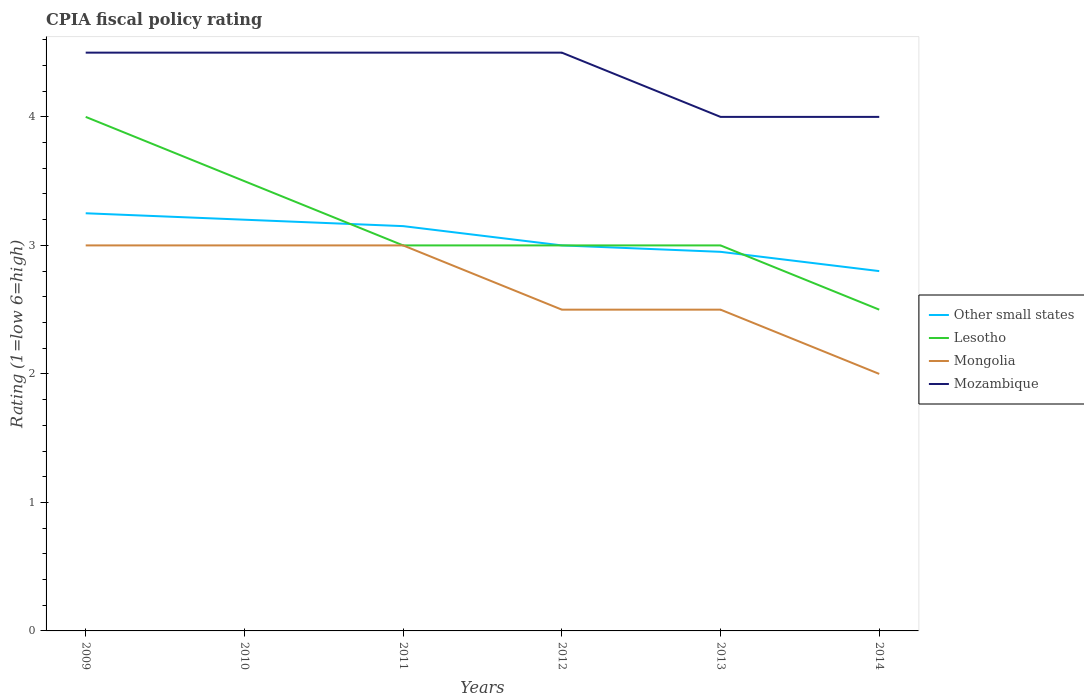Across all years, what is the maximum CPIA rating in Mozambique?
Your answer should be compact. 4. What is the total CPIA rating in Other small states in the graph?
Provide a succinct answer. 0.2. What is the difference between the highest and the second highest CPIA rating in Mongolia?
Ensure brevity in your answer.  1. What is the difference between the highest and the lowest CPIA rating in Lesotho?
Keep it short and to the point. 2. Is the CPIA rating in Mozambique strictly greater than the CPIA rating in Lesotho over the years?
Your answer should be very brief. No. How many years are there in the graph?
Your answer should be compact. 6. What is the difference between two consecutive major ticks on the Y-axis?
Your answer should be very brief. 1. Are the values on the major ticks of Y-axis written in scientific E-notation?
Keep it short and to the point. No. Does the graph contain grids?
Provide a short and direct response. No. What is the title of the graph?
Offer a terse response. CPIA fiscal policy rating. What is the Rating (1=low 6=high) in Other small states in 2009?
Keep it short and to the point. 3.25. What is the Rating (1=low 6=high) of Other small states in 2010?
Your answer should be very brief. 3.2. What is the Rating (1=low 6=high) of Lesotho in 2010?
Give a very brief answer. 3.5. What is the Rating (1=low 6=high) in Mongolia in 2010?
Your response must be concise. 3. What is the Rating (1=low 6=high) in Other small states in 2011?
Provide a succinct answer. 3.15. What is the Rating (1=low 6=high) in Lesotho in 2011?
Your answer should be very brief. 3. What is the Rating (1=low 6=high) in Other small states in 2012?
Make the answer very short. 3. What is the Rating (1=low 6=high) in Mongolia in 2012?
Ensure brevity in your answer.  2.5. What is the Rating (1=low 6=high) in Mozambique in 2012?
Give a very brief answer. 4.5. What is the Rating (1=low 6=high) in Other small states in 2013?
Give a very brief answer. 2.95. What is the Rating (1=low 6=high) of Lesotho in 2013?
Make the answer very short. 3. What is the Rating (1=low 6=high) of Mozambique in 2013?
Make the answer very short. 4. What is the Rating (1=low 6=high) of Mongolia in 2014?
Your response must be concise. 2. Across all years, what is the maximum Rating (1=low 6=high) in Lesotho?
Your answer should be very brief. 4. Across all years, what is the maximum Rating (1=low 6=high) of Mongolia?
Your answer should be very brief. 3. Across all years, what is the maximum Rating (1=low 6=high) of Mozambique?
Provide a short and direct response. 4.5. Across all years, what is the minimum Rating (1=low 6=high) in Lesotho?
Make the answer very short. 2.5. Across all years, what is the minimum Rating (1=low 6=high) in Mongolia?
Your response must be concise. 2. Across all years, what is the minimum Rating (1=low 6=high) in Mozambique?
Your answer should be very brief. 4. What is the total Rating (1=low 6=high) in Other small states in the graph?
Provide a short and direct response. 18.35. What is the difference between the Rating (1=low 6=high) in Lesotho in 2009 and that in 2010?
Make the answer very short. 0.5. What is the difference between the Rating (1=low 6=high) in Mongolia in 2009 and that in 2010?
Your answer should be very brief. 0. What is the difference between the Rating (1=low 6=high) in Mozambique in 2009 and that in 2010?
Provide a short and direct response. 0. What is the difference between the Rating (1=low 6=high) in Lesotho in 2009 and that in 2011?
Ensure brevity in your answer.  1. What is the difference between the Rating (1=low 6=high) in Mongolia in 2009 and that in 2011?
Provide a succinct answer. 0. What is the difference between the Rating (1=low 6=high) in Other small states in 2009 and that in 2012?
Ensure brevity in your answer.  0.25. What is the difference between the Rating (1=low 6=high) of Lesotho in 2009 and that in 2012?
Give a very brief answer. 1. What is the difference between the Rating (1=low 6=high) in Other small states in 2009 and that in 2013?
Your answer should be very brief. 0.3. What is the difference between the Rating (1=low 6=high) of Mozambique in 2009 and that in 2013?
Your answer should be very brief. 0.5. What is the difference between the Rating (1=low 6=high) of Other small states in 2009 and that in 2014?
Make the answer very short. 0.45. What is the difference between the Rating (1=low 6=high) in Mongolia in 2009 and that in 2014?
Your answer should be very brief. 1. What is the difference between the Rating (1=low 6=high) in Mozambique in 2009 and that in 2014?
Your response must be concise. 0.5. What is the difference between the Rating (1=low 6=high) of Other small states in 2010 and that in 2011?
Your answer should be compact. 0.05. What is the difference between the Rating (1=low 6=high) of Lesotho in 2010 and that in 2011?
Give a very brief answer. 0.5. What is the difference between the Rating (1=low 6=high) of Mozambique in 2010 and that in 2012?
Provide a succinct answer. 0. What is the difference between the Rating (1=low 6=high) of Other small states in 2010 and that in 2013?
Your response must be concise. 0.25. What is the difference between the Rating (1=low 6=high) in Mozambique in 2010 and that in 2013?
Your response must be concise. 0.5. What is the difference between the Rating (1=low 6=high) in Other small states in 2010 and that in 2014?
Give a very brief answer. 0.4. What is the difference between the Rating (1=low 6=high) of Lesotho in 2010 and that in 2014?
Your response must be concise. 1. What is the difference between the Rating (1=low 6=high) in Mozambique in 2010 and that in 2014?
Keep it short and to the point. 0.5. What is the difference between the Rating (1=low 6=high) in Other small states in 2011 and that in 2012?
Keep it short and to the point. 0.15. What is the difference between the Rating (1=low 6=high) of Other small states in 2011 and that in 2013?
Your answer should be very brief. 0.2. What is the difference between the Rating (1=low 6=high) in Mozambique in 2011 and that in 2013?
Keep it short and to the point. 0.5. What is the difference between the Rating (1=low 6=high) of Other small states in 2011 and that in 2014?
Make the answer very short. 0.35. What is the difference between the Rating (1=low 6=high) of Mongolia in 2011 and that in 2014?
Provide a succinct answer. 1. What is the difference between the Rating (1=low 6=high) in Mongolia in 2012 and that in 2013?
Offer a terse response. 0. What is the difference between the Rating (1=low 6=high) in Other small states in 2012 and that in 2014?
Your response must be concise. 0.2. What is the difference between the Rating (1=low 6=high) of Lesotho in 2012 and that in 2014?
Offer a very short reply. 0.5. What is the difference between the Rating (1=low 6=high) of Mongolia in 2012 and that in 2014?
Your answer should be very brief. 0.5. What is the difference between the Rating (1=low 6=high) of Mozambique in 2012 and that in 2014?
Ensure brevity in your answer.  0.5. What is the difference between the Rating (1=low 6=high) of Other small states in 2013 and that in 2014?
Give a very brief answer. 0.15. What is the difference between the Rating (1=low 6=high) in Mozambique in 2013 and that in 2014?
Offer a very short reply. 0. What is the difference between the Rating (1=low 6=high) of Other small states in 2009 and the Rating (1=low 6=high) of Mongolia in 2010?
Offer a terse response. 0.25. What is the difference between the Rating (1=low 6=high) of Other small states in 2009 and the Rating (1=low 6=high) of Mozambique in 2010?
Your answer should be very brief. -1.25. What is the difference between the Rating (1=low 6=high) of Lesotho in 2009 and the Rating (1=low 6=high) of Mozambique in 2010?
Offer a terse response. -0.5. What is the difference between the Rating (1=low 6=high) in Mongolia in 2009 and the Rating (1=low 6=high) in Mozambique in 2010?
Ensure brevity in your answer.  -1.5. What is the difference between the Rating (1=low 6=high) in Other small states in 2009 and the Rating (1=low 6=high) in Lesotho in 2011?
Offer a very short reply. 0.25. What is the difference between the Rating (1=low 6=high) in Other small states in 2009 and the Rating (1=low 6=high) in Mongolia in 2011?
Offer a terse response. 0.25. What is the difference between the Rating (1=low 6=high) in Other small states in 2009 and the Rating (1=low 6=high) in Mozambique in 2011?
Ensure brevity in your answer.  -1.25. What is the difference between the Rating (1=low 6=high) in Lesotho in 2009 and the Rating (1=low 6=high) in Mongolia in 2011?
Provide a short and direct response. 1. What is the difference between the Rating (1=low 6=high) in Other small states in 2009 and the Rating (1=low 6=high) in Mongolia in 2012?
Your answer should be very brief. 0.75. What is the difference between the Rating (1=low 6=high) of Other small states in 2009 and the Rating (1=low 6=high) of Mozambique in 2012?
Give a very brief answer. -1.25. What is the difference between the Rating (1=low 6=high) of Other small states in 2009 and the Rating (1=low 6=high) of Mozambique in 2013?
Offer a very short reply. -0.75. What is the difference between the Rating (1=low 6=high) of Lesotho in 2009 and the Rating (1=low 6=high) of Mozambique in 2013?
Ensure brevity in your answer.  0. What is the difference between the Rating (1=low 6=high) in Mongolia in 2009 and the Rating (1=low 6=high) in Mozambique in 2013?
Your response must be concise. -1. What is the difference between the Rating (1=low 6=high) in Other small states in 2009 and the Rating (1=low 6=high) in Lesotho in 2014?
Your response must be concise. 0.75. What is the difference between the Rating (1=low 6=high) in Other small states in 2009 and the Rating (1=low 6=high) in Mozambique in 2014?
Your response must be concise. -0.75. What is the difference between the Rating (1=low 6=high) of Lesotho in 2009 and the Rating (1=low 6=high) of Mozambique in 2014?
Offer a terse response. 0. What is the difference between the Rating (1=low 6=high) of Mongolia in 2009 and the Rating (1=low 6=high) of Mozambique in 2014?
Keep it short and to the point. -1. What is the difference between the Rating (1=low 6=high) of Other small states in 2010 and the Rating (1=low 6=high) of Mozambique in 2011?
Provide a succinct answer. -1.3. What is the difference between the Rating (1=low 6=high) of Lesotho in 2010 and the Rating (1=low 6=high) of Mozambique in 2011?
Your answer should be very brief. -1. What is the difference between the Rating (1=low 6=high) of Other small states in 2010 and the Rating (1=low 6=high) of Lesotho in 2012?
Keep it short and to the point. 0.2. What is the difference between the Rating (1=low 6=high) of Other small states in 2010 and the Rating (1=low 6=high) of Mongolia in 2012?
Keep it short and to the point. 0.7. What is the difference between the Rating (1=low 6=high) of Other small states in 2010 and the Rating (1=low 6=high) of Mozambique in 2012?
Provide a short and direct response. -1.3. What is the difference between the Rating (1=low 6=high) in Lesotho in 2010 and the Rating (1=low 6=high) in Mozambique in 2012?
Make the answer very short. -1. What is the difference between the Rating (1=low 6=high) in Other small states in 2010 and the Rating (1=low 6=high) in Lesotho in 2013?
Keep it short and to the point. 0.2. What is the difference between the Rating (1=low 6=high) of Other small states in 2010 and the Rating (1=low 6=high) of Mongolia in 2013?
Provide a succinct answer. 0.7. What is the difference between the Rating (1=low 6=high) of Other small states in 2010 and the Rating (1=low 6=high) of Mozambique in 2013?
Offer a terse response. -0.8. What is the difference between the Rating (1=low 6=high) of Lesotho in 2010 and the Rating (1=low 6=high) of Mozambique in 2013?
Make the answer very short. -0.5. What is the difference between the Rating (1=low 6=high) of Mongolia in 2010 and the Rating (1=low 6=high) of Mozambique in 2013?
Give a very brief answer. -1. What is the difference between the Rating (1=low 6=high) in Other small states in 2010 and the Rating (1=low 6=high) in Mongolia in 2014?
Keep it short and to the point. 1.2. What is the difference between the Rating (1=low 6=high) in Other small states in 2010 and the Rating (1=low 6=high) in Mozambique in 2014?
Keep it short and to the point. -0.8. What is the difference between the Rating (1=low 6=high) of Lesotho in 2010 and the Rating (1=low 6=high) of Mozambique in 2014?
Provide a succinct answer. -0.5. What is the difference between the Rating (1=low 6=high) of Other small states in 2011 and the Rating (1=low 6=high) of Mongolia in 2012?
Ensure brevity in your answer.  0.65. What is the difference between the Rating (1=low 6=high) in Other small states in 2011 and the Rating (1=low 6=high) in Mozambique in 2012?
Keep it short and to the point. -1.35. What is the difference between the Rating (1=low 6=high) of Lesotho in 2011 and the Rating (1=low 6=high) of Mongolia in 2012?
Your response must be concise. 0.5. What is the difference between the Rating (1=low 6=high) in Lesotho in 2011 and the Rating (1=low 6=high) in Mozambique in 2012?
Make the answer very short. -1.5. What is the difference between the Rating (1=low 6=high) of Other small states in 2011 and the Rating (1=low 6=high) of Mongolia in 2013?
Give a very brief answer. 0.65. What is the difference between the Rating (1=low 6=high) in Other small states in 2011 and the Rating (1=low 6=high) in Mozambique in 2013?
Provide a short and direct response. -0.85. What is the difference between the Rating (1=low 6=high) in Lesotho in 2011 and the Rating (1=low 6=high) in Mozambique in 2013?
Provide a short and direct response. -1. What is the difference between the Rating (1=low 6=high) in Mongolia in 2011 and the Rating (1=low 6=high) in Mozambique in 2013?
Your response must be concise. -1. What is the difference between the Rating (1=low 6=high) of Other small states in 2011 and the Rating (1=low 6=high) of Lesotho in 2014?
Your answer should be very brief. 0.65. What is the difference between the Rating (1=low 6=high) in Other small states in 2011 and the Rating (1=low 6=high) in Mongolia in 2014?
Your answer should be compact. 1.15. What is the difference between the Rating (1=low 6=high) in Other small states in 2011 and the Rating (1=low 6=high) in Mozambique in 2014?
Provide a succinct answer. -0.85. What is the difference between the Rating (1=low 6=high) in Other small states in 2012 and the Rating (1=low 6=high) in Mongolia in 2013?
Provide a succinct answer. 0.5. What is the difference between the Rating (1=low 6=high) of Other small states in 2012 and the Rating (1=low 6=high) of Mozambique in 2013?
Provide a succinct answer. -1. What is the difference between the Rating (1=low 6=high) of Lesotho in 2012 and the Rating (1=low 6=high) of Mongolia in 2013?
Give a very brief answer. 0.5. What is the difference between the Rating (1=low 6=high) in Mongolia in 2012 and the Rating (1=low 6=high) in Mozambique in 2013?
Your response must be concise. -1.5. What is the difference between the Rating (1=low 6=high) of Other small states in 2012 and the Rating (1=low 6=high) of Lesotho in 2014?
Keep it short and to the point. 0.5. What is the difference between the Rating (1=low 6=high) of Lesotho in 2012 and the Rating (1=low 6=high) of Mozambique in 2014?
Your answer should be compact. -1. What is the difference between the Rating (1=low 6=high) of Other small states in 2013 and the Rating (1=low 6=high) of Lesotho in 2014?
Your response must be concise. 0.45. What is the difference between the Rating (1=low 6=high) in Other small states in 2013 and the Rating (1=low 6=high) in Mongolia in 2014?
Provide a succinct answer. 0.95. What is the difference between the Rating (1=low 6=high) of Other small states in 2013 and the Rating (1=low 6=high) of Mozambique in 2014?
Your answer should be compact. -1.05. What is the difference between the Rating (1=low 6=high) in Lesotho in 2013 and the Rating (1=low 6=high) in Mozambique in 2014?
Offer a very short reply. -1. What is the difference between the Rating (1=low 6=high) in Mongolia in 2013 and the Rating (1=low 6=high) in Mozambique in 2014?
Make the answer very short. -1.5. What is the average Rating (1=low 6=high) of Other small states per year?
Offer a very short reply. 3.06. What is the average Rating (1=low 6=high) of Lesotho per year?
Your answer should be very brief. 3.17. What is the average Rating (1=low 6=high) in Mongolia per year?
Your answer should be very brief. 2.67. What is the average Rating (1=low 6=high) of Mozambique per year?
Provide a succinct answer. 4.33. In the year 2009, what is the difference between the Rating (1=low 6=high) of Other small states and Rating (1=low 6=high) of Lesotho?
Give a very brief answer. -0.75. In the year 2009, what is the difference between the Rating (1=low 6=high) of Other small states and Rating (1=low 6=high) of Mozambique?
Provide a succinct answer. -1.25. In the year 2010, what is the difference between the Rating (1=low 6=high) of Other small states and Rating (1=low 6=high) of Mozambique?
Your answer should be very brief. -1.3. In the year 2010, what is the difference between the Rating (1=low 6=high) of Lesotho and Rating (1=low 6=high) of Mongolia?
Keep it short and to the point. 0.5. In the year 2011, what is the difference between the Rating (1=low 6=high) in Other small states and Rating (1=low 6=high) in Mozambique?
Provide a short and direct response. -1.35. In the year 2011, what is the difference between the Rating (1=low 6=high) of Lesotho and Rating (1=low 6=high) of Mongolia?
Your response must be concise. 0. In the year 2011, what is the difference between the Rating (1=low 6=high) of Mongolia and Rating (1=low 6=high) of Mozambique?
Provide a short and direct response. -1.5. In the year 2012, what is the difference between the Rating (1=low 6=high) of Lesotho and Rating (1=low 6=high) of Mongolia?
Your response must be concise. 0.5. In the year 2012, what is the difference between the Rating (1=low 6=high) of Lesotho and Rating (1=low 6=high) of Mozambique?
Provide a short and direct response. -1.5. In the year 2013, what is the difference between the Rating (1=low 6=high) of Other small states and Rating (1=low 6=high) of Mongolia?
Keep it short and to the point. 0.45. In the year 2013, what is the difference between the Rating (1=low 6=high) of Other small states and Rating (1=low 6=high) of Mozambique?
Provide a succinct answer. -1.05. In the year 2013, what is the difference between the Rating (1=low 6=high) of Mongolia and Rating (1=low 6=high) of Mozambique?
Make the answer very short. -1.5. In the year 2014, what is the difference between the Rating (1=low 6=high) of Other small states and Rating (1=low 6=high) of Mongolia?
Make the answer very short. 0.8. In the year 2014, what is the difference between the Rating (1=low 6=high) in Other small states and Rating (1=low 6=high) in Mozambique?
Offer a very short reply. -1.2. What is the ratio of the Rating (1=low 6=high) in Other small states in 2009 to that in 2010?
Make the answer very short. 1.02. What is the ratio of the Rating (1=low 6=high) of Lesotho in 2009 to that in 2010?
Your answer should be compact. 1.14. What is the ratio of the Rating (1=low 6=high) of Mongolia in 2009 to that in 2010?
Your response must be concise. 1. What is the ratio of the Rating (1=low 6=high) of Mozambique in 2009 to that in 2010?
Give a very brief answer. 1. What is the ratio of the Rating (1=low 6=high) of Other small states in 2009 to that in 2011?
Offer a terse response. 1.03. What is the ratio of the Rating (1=low 6=high) of Lesotho in 2009 to that in 2011?
Keep it short and to the point. 1.33. What is the ratio of the Rating (1=low 6=high) of Other small states in 2009 to that in 2012?
Provide a succinct answer. 1.08. What is the ratio of the Rating (1=low 6=high) in Mongolia in 2009 to that in 2012?
Make the answer very short. 1.2. What is the ratio of the Rating (1=low 6=high) of Other small states in 2009 to that in 2013?
Your answer should be very brief. 1.1. What is the ratio of the Rating (1=low 6=high) of Lesotho in 2009 to that in 2013?
Your answer should be compact. 1.33. What is the ratio of the Rating (1=low 6=high) of Mongolia in 2009 to that in 2013?
Offer a terse response. 1.2. What is the ratio of the Rating (1=low 6=high) of Mozambique in 2009 to that in 2013?
Your answer should be very brief. 1.12. What is the ratio of the Rating (1=low 6=high) of Other small states in 2009 to that in 2014?
Give a very brief answer. 1.16. What is the ratio of the Rating (1=low 6=high) of Mongolia in 2009 to that in 2014?
Offer a terse response. 1.5. What is the ratio of the Rating (1=low 6=high) in Mozambique in 2009 to that in 2014?
Give a very brief answer. 1.12. What is the ratio of the Rating (1=low 6=high) in Other small states in 2010 to that in 2011?
Provide a succinct answer. 1.02. What is the ratio of the Rating (1=low 6=high) in Lesotho in 2010 to that in 2011?
Provide a short and direct response. 1.17. What is the ratio of the Rating (1=low 6=high) of Mongolia in 2010 to that in 2011?
Your response must be concise. 1. What is the ratio of the Rating (1=low 6=high) of Mozambique in 2010 to that in 2011?
Your answer should be compact. 1. What is the ratio of the Rating (1=low 6=high) in Other small states in 2010 to that in 2012?
Ensure brevity in your answer.  1.07. What is the ratio of the Rating (1=low 6=high) of Other small states in 2010 to that in 2013?
Your response must be concise. 1.08. What is the ratio of the Rating (1=low 6=high) in Lesotho in 2010 to that in 2013?
Your answer should be compact. 1.17. What is the ratio of the Rating (1=low 6=high) in Mozambique in 2010 to that in 2013?
Your answer should be compact. 1.12. What is the ratio of the Rating (1=low 6=high) of Other small states in 2010 to that in 2014?
Give a very brief answer. 1.14. What is the ratio of the Rating (1=low 6=high) of Lesotho in 2010 to that in 2014?
Ensure brevity in your answer.  1.4. What is the ratio of the Rating (1=low 6=high) of Mongolia in 2010 to that in 2014?
Make the answer very short. 1.5. What is the ratio of the Rating (1=low 6=high) in Other small states in 2011 to that in 2012?
Offer a very short reply. 1.05. What is the ratio of the Rating (1=low 6=high) of Lesotho in 2011 to that in 2012?
Make the answer very short. 1. What is the ratio of the Rating (1=low 6=high) of Mozambique in 2011 to that in 2012?
Keep it short and to the point. 1. What is the ratio of the Rating (1=low 6=high) of Other small states in 2011 to that in 2013?
Your answer should be compact. 1.07. What is the ratio of the Rating (1=low 6=high) of Other small states in 2011 to that in 2014?
Make the answer very short. 1.12. What is the ratio of the Rating (1=low 6=high) in Mozambique in 2011 to that in 2014?
Give a very brief answer. 1.12. What is the ratio of the Rating (1=low 6=high) of Other small states in 2012 to that in 2013?
Make the answer very short. 1.02. What is the ratio of the Rating (1=low 6=high) in Lesotho in 2012 to that in 2013?
Ensure brevity in your answer.  1. What is the ratio of the Rating (1=low 6=high) in Mongolia in 2012 to that in 2013?
Make the answer very short. 1. What is the ratio of the Rating (1=low 6=high) of Mozambique in 2012 to that in 2013?
Provide a short and direct response. 1.12. What is the ratio of the Rating (1=low 6=high) of Other small states in 2012 to that in 2014?
Ensure brevity in your answer.  1.07. What is the ratio of the Rating (1=low 6=high) in Lesotho in 2012 to that in 2014?
Give a very brief answer. 1.2. What is the ratio of the Rating (1=low 6=high) in Mongolia in 2012 to that in 2014?
Your response must be concise. 1.25. What is the ratio of the Rating (1=low 6=high) in Mozambique in 2012 to that in 2014?
Make the answer very short. 1.12. What is the ratio of the Rating (1=low 6=high) in Other small states in 2013 to that in 2014?
Your answer should be very brief. 1.05. What is the ratio of the Rating (1=low 6=high) in Mongolia in 2013 to that in 2014?
Ensure brevity in your answer.  1.25. What is the difference between the highest and the second highest Rating (1=low 6=high) in Other small states?
Make the answer very short. 0.05. What is the difference between the highest and the second highest Rating (1=low 6=high) of Lesotho?
Provide a short and direct response. 0.5. What is the difference between the highest and the second highest Rating (1=low 6=high) in Mongolia?
Your answer should be compact. 0. What is the difference between the highest and the lowest Rating (1=low 6=high) of Other small states?
Your response must be concise. 0.45. What is the difference between the highest and the lowest Rating (1=low 6=high) of Mongolia?
Ensure brevity in your answer.  1. 